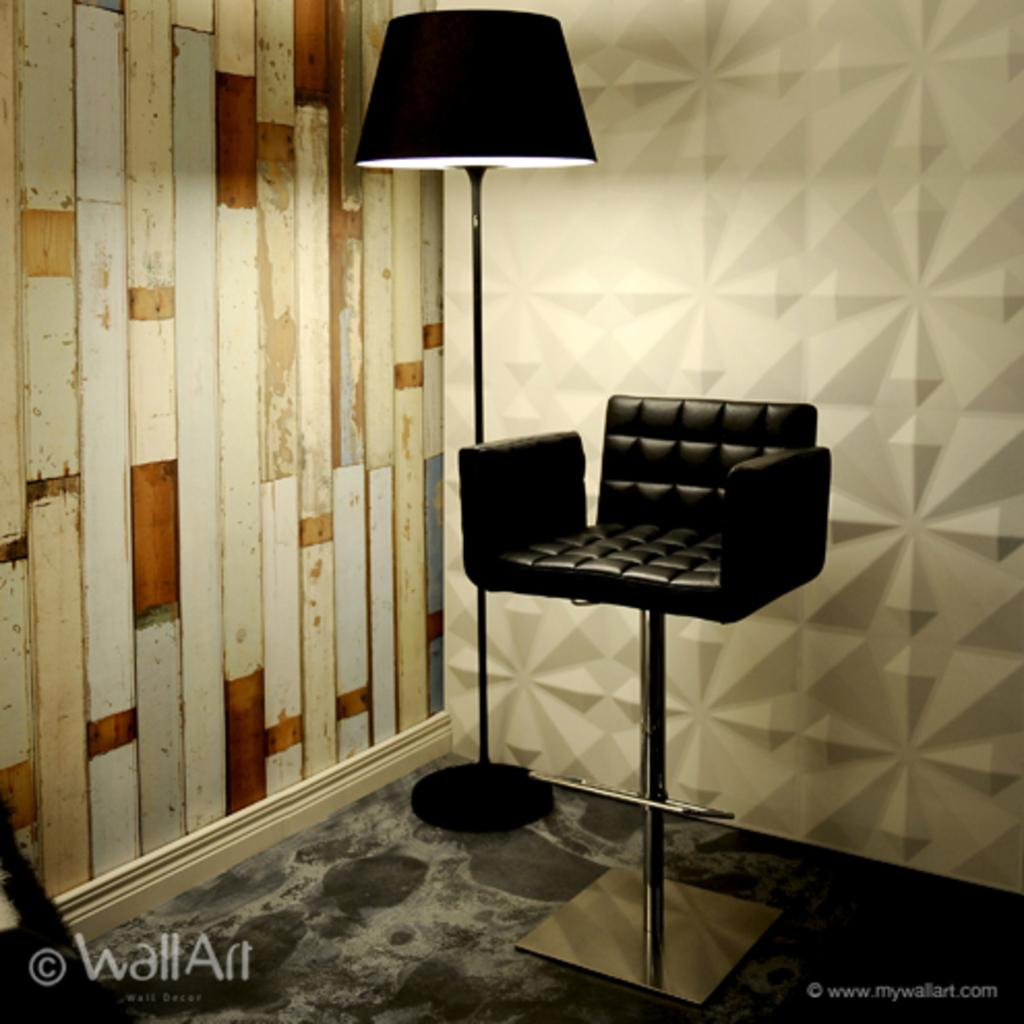What type of furniture is in the middle of the image? There is a chair in the image. What other object is in the middle of the image? There is a lamp in the image. What is located on the left side of the image? There is a wall on the left side of the image. What can be found at the right bottom of the image? There is some text at the right bottom of the image. What is visible in the background of the image? There is wall art in the background of the image. What is the acoustics like in the room depicted in the image? The provided facts do not give any information about the acoustics in the room, so it cannot be determined from the image. 